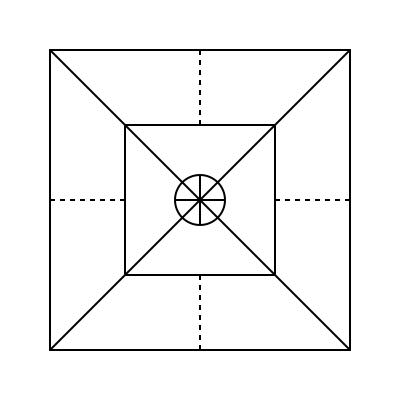In this geometric pattern inspired by Lithuanian folk art tapestries, how many distinct shapes can you identify? To solve this puzzle, let's break down the pattern and identify each distinct shape:

1. Large square: The outermost shape forming the border of the pattern.
2. Large X: Formed by the diagonal lines connecting the corners of the large square.
3. Small square: The inner square centered within the large square.
4. Circle: Located at the center of the pattern.
5. Small X: Formed by the two intersecting lines within the circle.
6. Triangles: Four triangles are formed in the corners between the large square and the small square.

It's important to note that while there are multiple instances of some shapes (e.g., four triangles), we count them as one distinct shape type.

Additionally, the dashed lines connecting the midpoints of the sides of the large square to the small square do not form a new shape but rather serve as decorative elements, typical in Lithuanian folk art.

Therefore, the total count of distinct shapes in this pattern is 6.
Answer: 6 